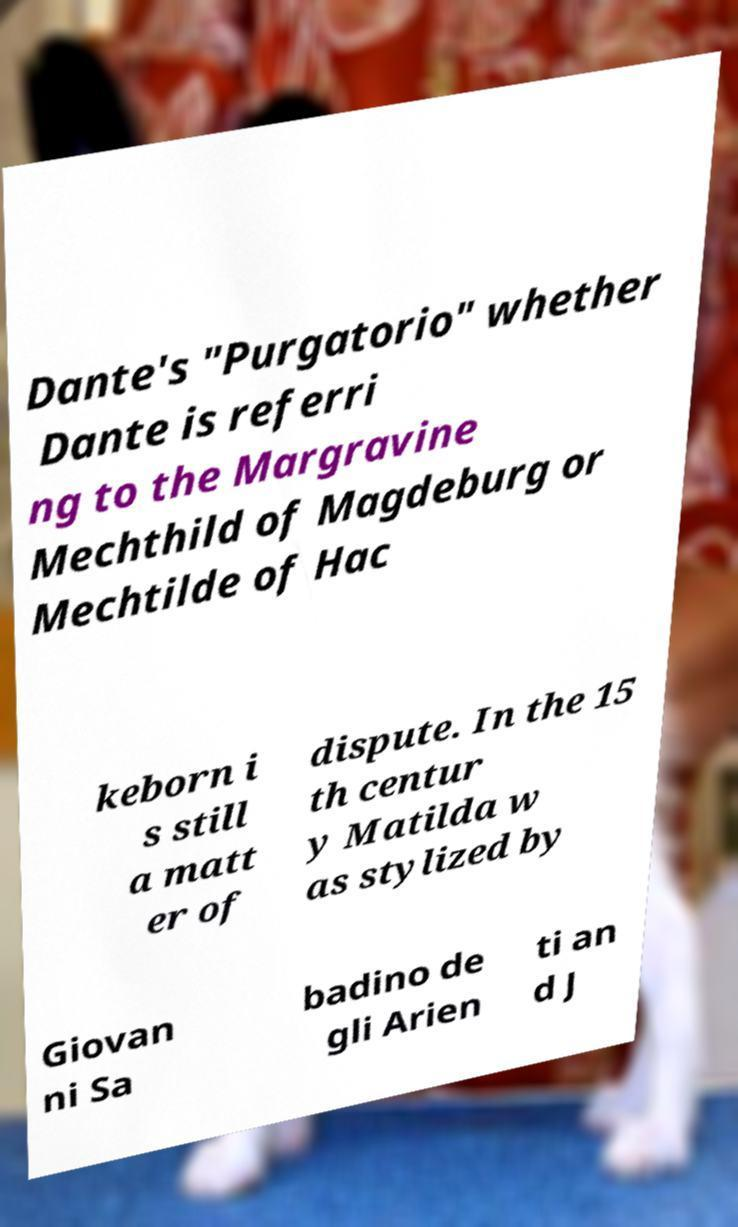For documentation purposes, I need the text within this image transcribed. Could you provide that? Dante's "Purgatorio" whether Dante is referri ng to the Margravine Mechthild of Magdeburg or Mechtilde of Hac keborn i s still a matt er of dispute. In the 15 th centur y Matilda w as stylized by Giovan ni Sa badino de gli Arien ti an d J 